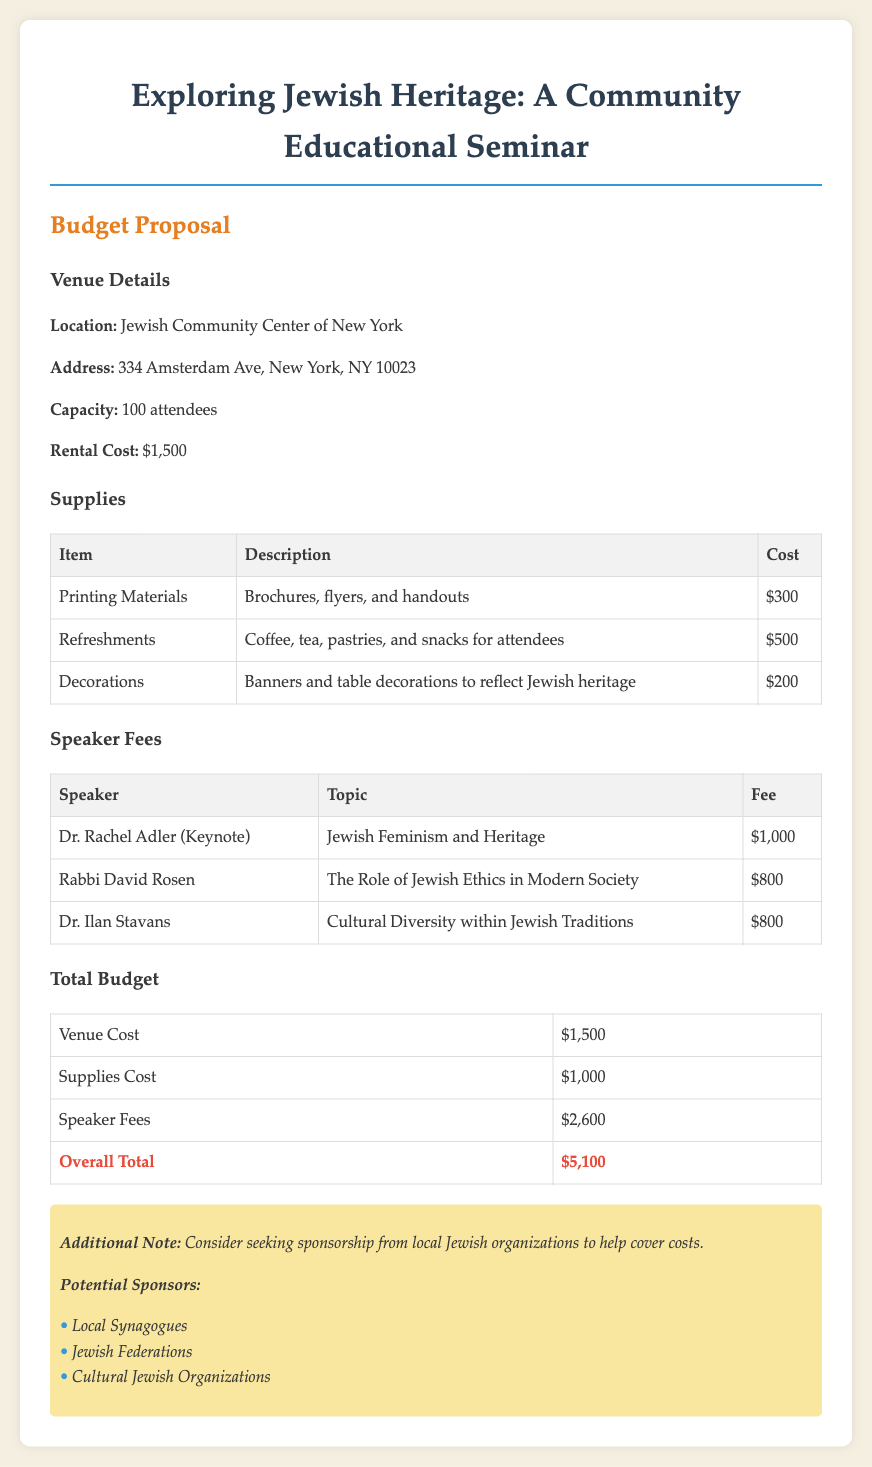What is the location of the seminar? The location is specifically mentioned in the document as the Jewish Community Center of New York.
Answer: Jewish Community Center of New York What is the rental cost for the venue? The rental cost for the venue is clearly stated in the document.
Answer: $1,500 How many attendees can the venue accommodate? The document provides the capacity of the venue for attendees.
Answer: 100 attendees What is the fee for Dr. Rachel Adler? The fee for Dr. Rachel Adler is listed as the payment for her keynote speech.
Answer: $1,000 What are the total projected expenses for supplies? Total projected expenses for supplies are given in the document as the sum of all supply costs.
Answer: $1,000 Who is the speaker discussing Jewish Feminism? The document notes the specific speaker for that topic.
Answer: Dr. Rachel Adler What is the overall total budget for the seminar? The overall total budget is calculated based on all costs included in the proposal.
Answer: $5,100 Which organization is suggested for potential sponsorship? The document lists a specific type of organization that is suggested for sponsorship.
Answer: Local Synagogues How much does the seminar allocate for refreshments? The document specifies the amount dedicated to refreshments for attendees.
Answer: $500 What type of materials are included in the printing costs? The document describes what is covered under printing materials expenses.
Answer: Brochures, flyers, and handouts 